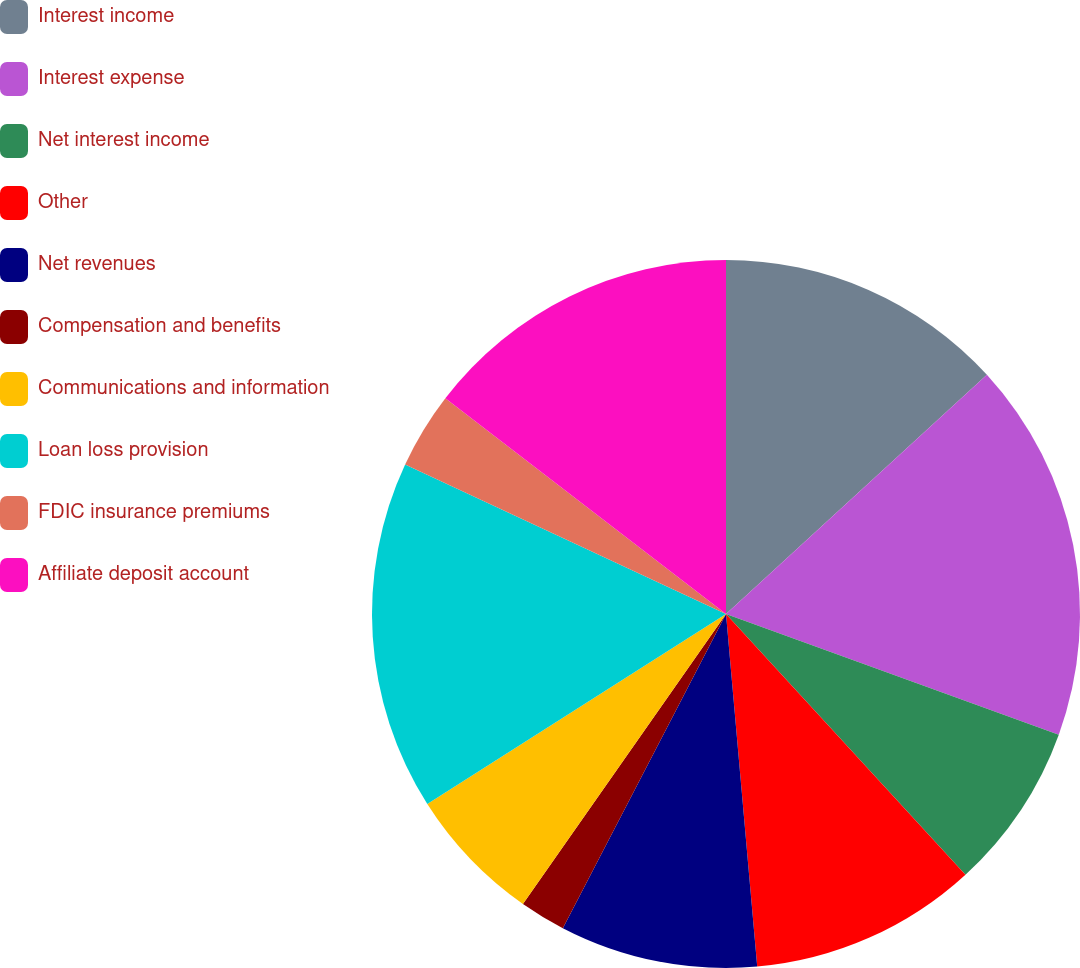Convert chart. <chart><loc_0><loc_0><loc_500><loc_500><pie_chart><fcel>Interest income<fcel>Interest expense<fcel>Net interest income<fcel>Other<fcel>Net revenues<fcel>Compensation and benefits<fcel>Communications and information<fcel>Loan loss provision<fcel>FDIC insurance premiums<fcel>Affiliate deposit account<nl><fcel>13.19%<fcel>17.35%<fcel>7.64%<fcel>10.42%<fcel>9.03%<fcel>2.1%<fcel>6.26%<fcel>15.96%<fcel>3.49%<fcel>14.57%<nl></chart> 